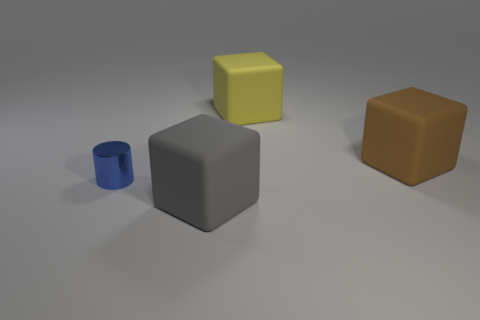Add 1 tiny blue metal cylinders. How many objects exist? 5 Subtract all gray cubes. How many cubes are left? 2 Subtract all cubes. How many objects are left? 1 Subtract all big yellow things. Subtract all large brown rubber blocks. How many objects are left? 2 Add 2 large gray things. How many large gray things are left? 3 Add 3 shiny cubes. How many shiny cubes exist? 3 Subtract 0 cyan cylinders. How many objects are left? 4 Subtract 2 cubes. How many cubes are left? 1 Subtract all red cylinders. Subtract all blue spheres. How many cylinders are left? 1 